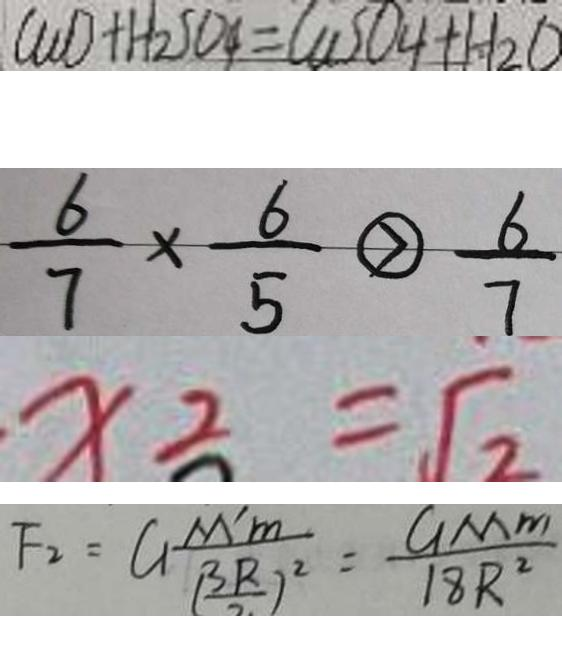<formula> <loc_0><loc_0><loc_500><loc_500>C u O + H _ { 2 } S O _ { 4 } = C u S O _ { 4 } + H _ { 2 } O 
 \frac { 6 } { 7 } \times \frac { 6 } { 5 } \textcircled { > } \frac { 6 } { 7 } 
 x _ { 2 } = \sqrt { 2 } 
 F _ { 2 } = G \frac { M ^ { \prime } m } { ( \frac { 3 R } { 2 } ) ^ { 2 } } = \frac { G M m } { 1 8 R ^ { 2 } }</formula> 